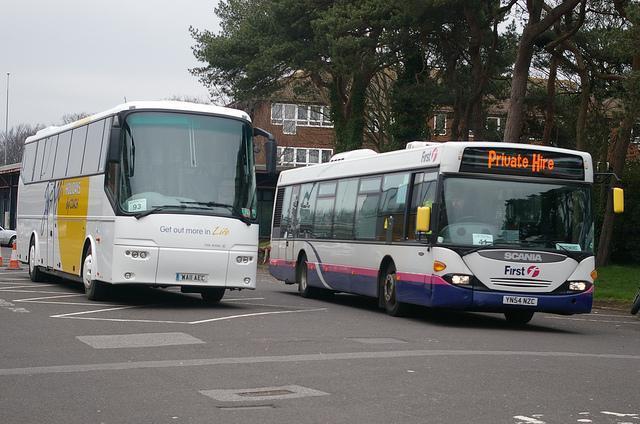How many buses are lined up?
Give a very brief answer. 2. How many busses are there?
Give a very brief answer. 2. How many buses are in a row?
Give a very brief answer. 2. How many buses are there?
Give a very brief answer. 2. 